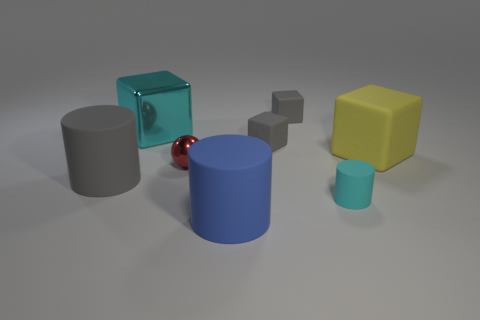How many large blue things are the same shape as the tiny cyan rubber object?
Give a very brief answer. 1. There is a cube that is the same color as the tiny cylinder; what is it made of?
Make the answer very short. Metal. Does the matte cylinder that is to the left of the tiny metallic object have the same size as the block to the left of the tiny red metallic sphere?
Your answer should be compact. Yes. There is a tiny thing that is in front of the gray rubber cylinder; what is its shape?
Your answer should be compact. Cylinder. What material is the large yellow object that is the same shape as the big cyan thing?
Provide a short and direct response. Rubber. There is a cyan thing on the left side of the metallic ball; is it the same size as the large gray cylinder?
Offer a terse response. Yes. There is a small ball; how many big metal things are to the left of it?
Your answer should be very brief. 1. Is the number of tiny cyan objects on the left side of the cyan shiny object less than the number of large objects that are in front of the tiny cyan rubber cylinder?
Make the answer very short. Yes. What number of small green shiny cylinders are there?
Give a very brief answer. 0. What color is the big matte thing right of the blue cylinder?
Offer a very short reply. Yellow. 